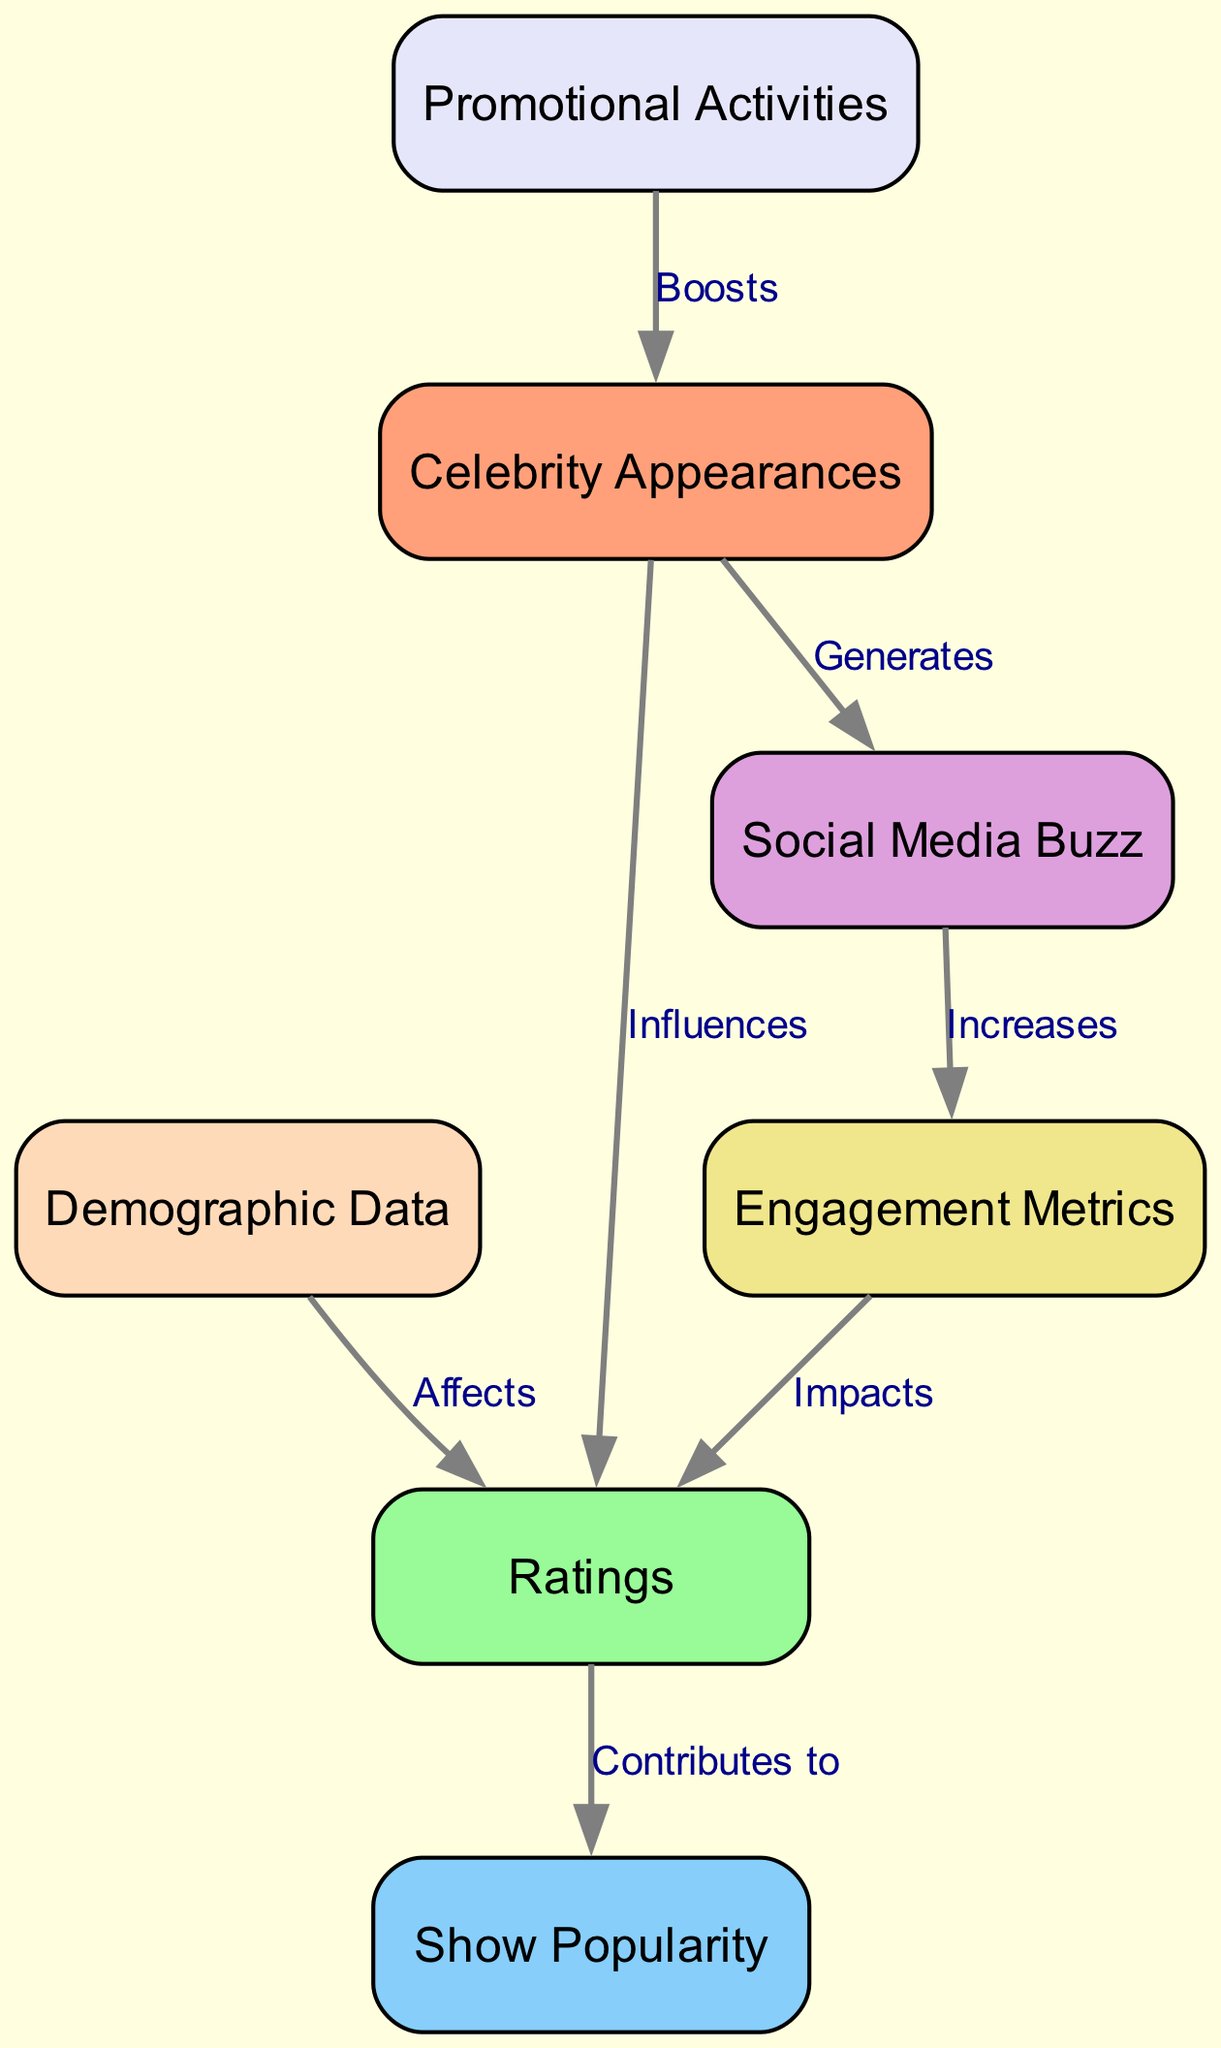What is the total number of nodes in the diagram? The diagram has seven nodes, as counted from the list of nodes provided in the data.
Answer: 7 Which node is influenced by Celebrity Appearances? The connection shows that Celebrity Appearances influence Ratings; therefore, Ratings is the node.
Answer: Ratings How many edges connect Show Popularity to other nodes? Show Popularity connects to Ratings through one edge, as seen in the connections; there are no further connections originating from Show Popularity.
Answer: 1 What relationship does Social Media Buzz have with Engagement Metrics? The diagram indicates that Social Media Buzz increases Engagement Metrics, establishing a directional relationship from Social Media Buzz to Engagement Metrics.
Answer: Increases Which node affects Ratings? The Demographic Data is indicated to affect Ratings, as per the diagram's connections.
Answer: Demographic Data What nodes does Ratings contribute to? Ratings contributes to Show Popularity, which establishes a direct effect according to the connections presented in the diagram.
Answer: Show Popularity What effect do Promotional Activities have on Celebrity Appearances? The diagram specifies that Promotional Activities boost Celebrity Appearances, creating a supportive relationship in the flow of the information.
Answer: Boosts In terms of viewer engagement, what does Engagement Metrics impact? The Engagement Metrics impacts Ratings, showing an influence on viewer perceptions and preferences regarding the shows.
Answer: Ratings How is Social Media Buzz generated? Social Media Buzz is generated from Celebrity Appearances, demonstrating a connection that suggests more celebrity presence leads to increased discussions online.
Answer: Generates 